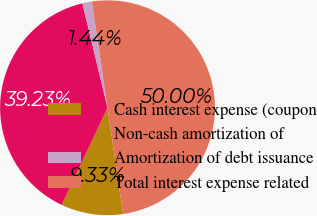Convert chart. <chart><loc_0><loc_0><loc_500><loc_500><pie_chart><fcel>Cash interest expense (coupon<fcel>Non-cash amortization of<fcel>Amortization of debt issuance<fcel>Total interest expense related<nl><fcel>9.33%<fcel>39.23%<fcel>1.44%<fcel>50.0%<nl></chart> 